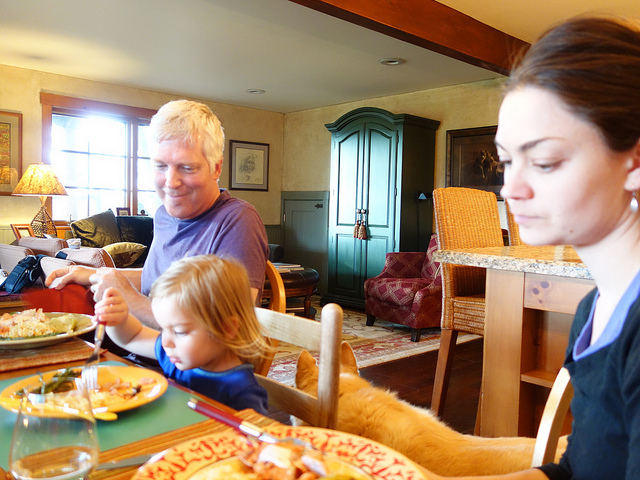How many chairs are in the picture? 3 